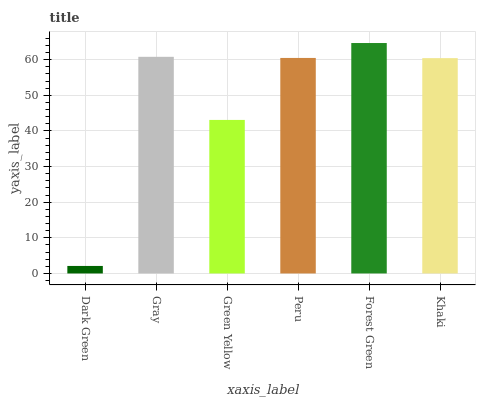Is Dark Green the minimum?
Answer yes or no. Yes. Is Forest Green the maximum?
Answer yes or no. Yes. Is Gray the minimum?
Answer yes or no. No. Is Gray the maximum?
Answer yes or no. No. Is Gray greater than Dark Green?
Answer yes or no. Yes. Is Dark Green less than Gray?
Answer yes or no. Yes. Is Dark Green greater than Gray?
Answer yes or no. No. Is Gray less than Dark Green?
Answer yes or no. No. Is Peru the high median?
Answer yes or no. Yes. Is Khaki the low median?
Answer yes or no. Yes. Is Gray the high median?
Answer yes or no. No. Is Green Yellow the low median?
Answer yes or no. No. 